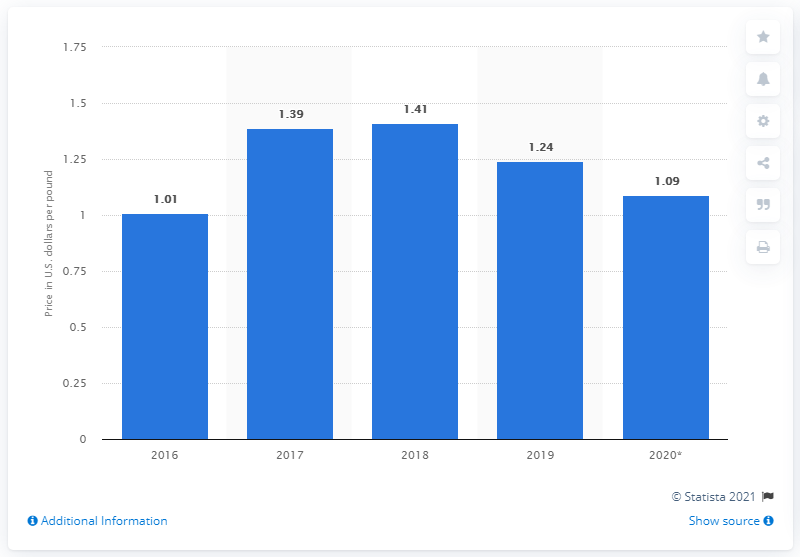List a handful of essential elements in this visual. In 2020, the dollar value of zinc per pound in North America was 1.09. 